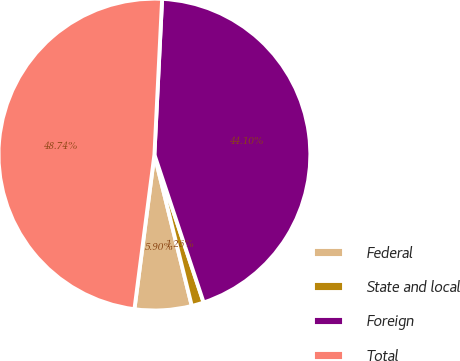Convert chart to OTSL. <chart><loc_0><loc_0><loc_500><loc_500><pie_chart><fcel>Federal<fcel>State and local<fcel>Foreign<fcel>Total<nl><fcel>5.9%<fcel>1.26%<fcel>44.1%<fcel>48.74%<nl></chart> 